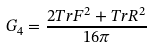Convert formula to latex. <formula><loc_0><loc_0><loc_500><loc_500>G _ { 4 } = \frac { 2 T r F ^ { 2 } + T r R ^ { 2 } } { 1 6 \pi }</formula> 